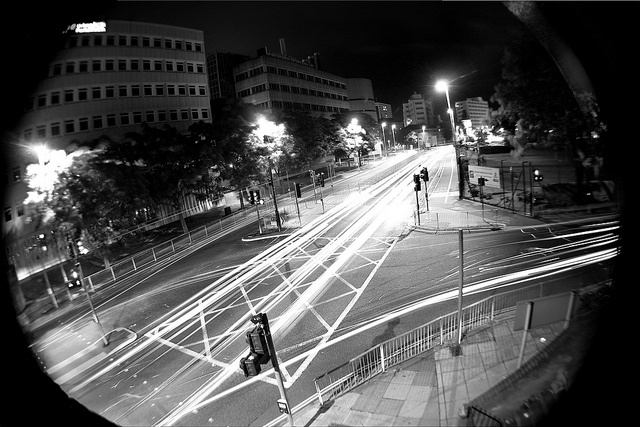Describe the objects in this image and their specific colors. I can see traffic light in black, gray, darkgray, and lightgray tones, traffic light in black, gray, white, and darkgray tones, traffic light in black, gray, white, and darkgray tones, traffic light in black, gray, darkgray, and gainsboro tones, and traffic light in black, gray, lightgray, and darkgray tones in this image. 